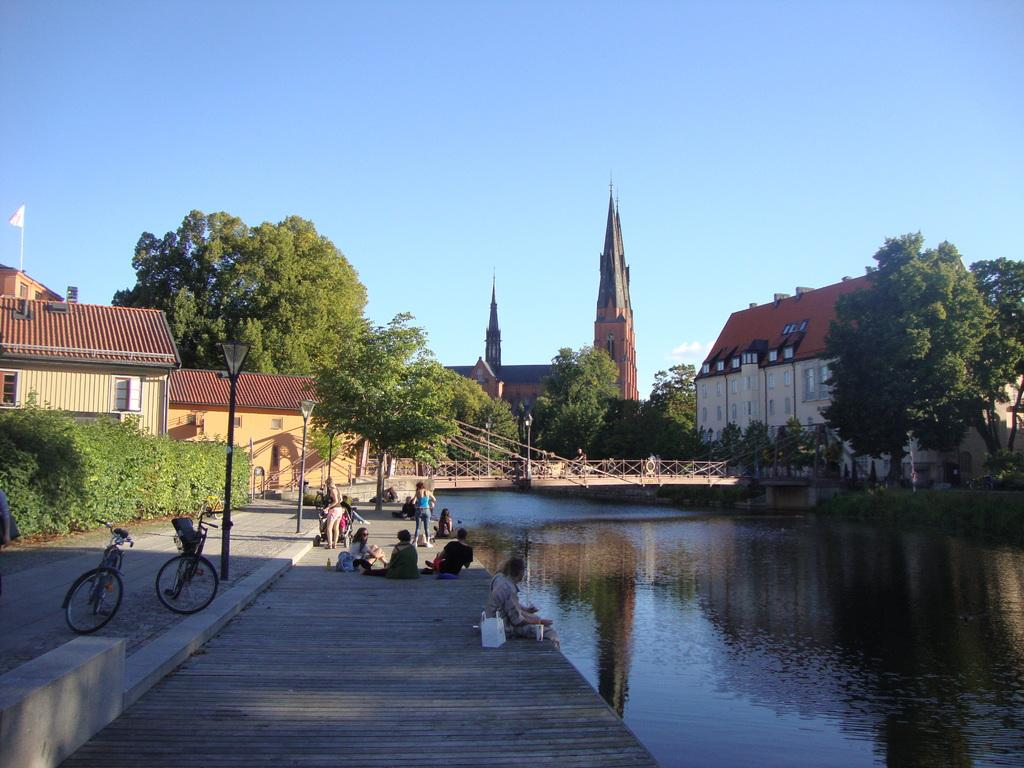What body of water is present in the image? There is a lake in the picture. What are the people near the lake doing? The people are sitting near the lake. What mode of transportation can be seen in the image? There are bicycles in the picture. What type of structures are visible in the image? There are buildings in the picture. What is the condition of the sky in the image? The sky is clear in the image. In which direction is the church located in the image? There is no church present in the image. How much sugar is dissolved in the lake in the image? There is no sugar present in the lake in the image. 